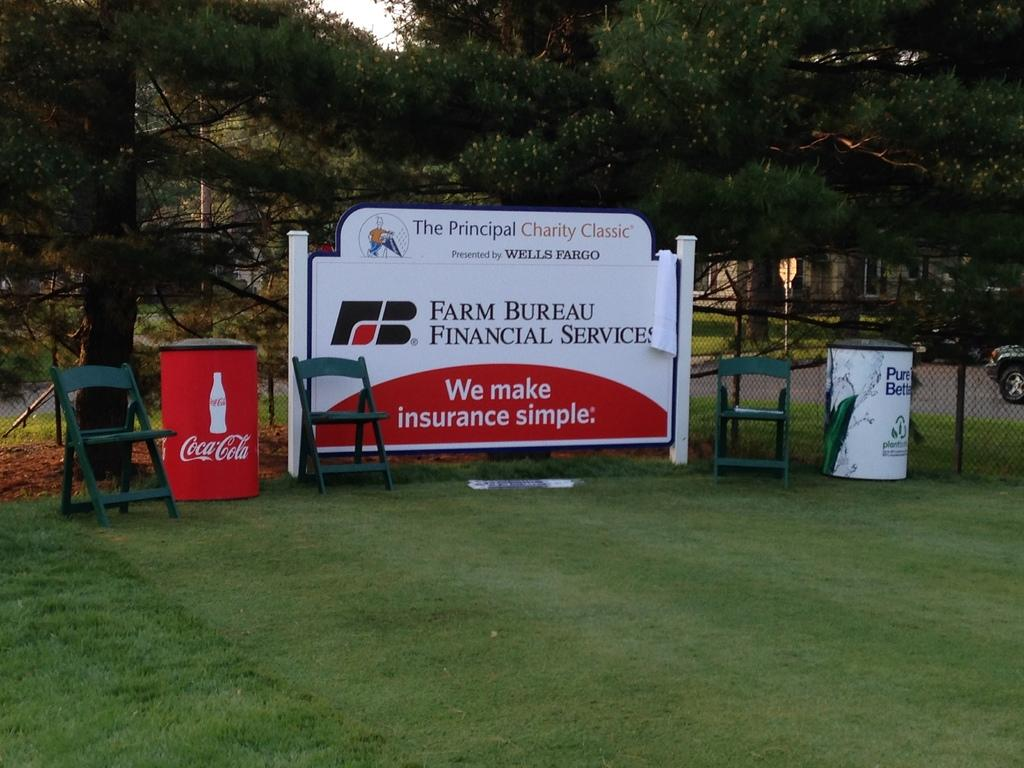What type of furniture is present in the image? There are chairs in the image. What type of natural environment is visible in the image? There are trees and grass in the image. What type of barrier is present in the image? There is a fence in the image. What type of transportation is visible in the image? There are vehicles in the image. What type of structure is present in the image? There is a house in the image. What type of signage is present in the image? There is a board with text in the image. What other objects can be seen in the image? There are poles and other objects in the image. Can you see any cracks in the house in the image? There is no mention of cracks in the house in the image, so it cannot be determined from the provided facts. Are there any ghosts visible in the image? There is no mention of ghosts in the image, so it cannot be determined from the provided facts. 